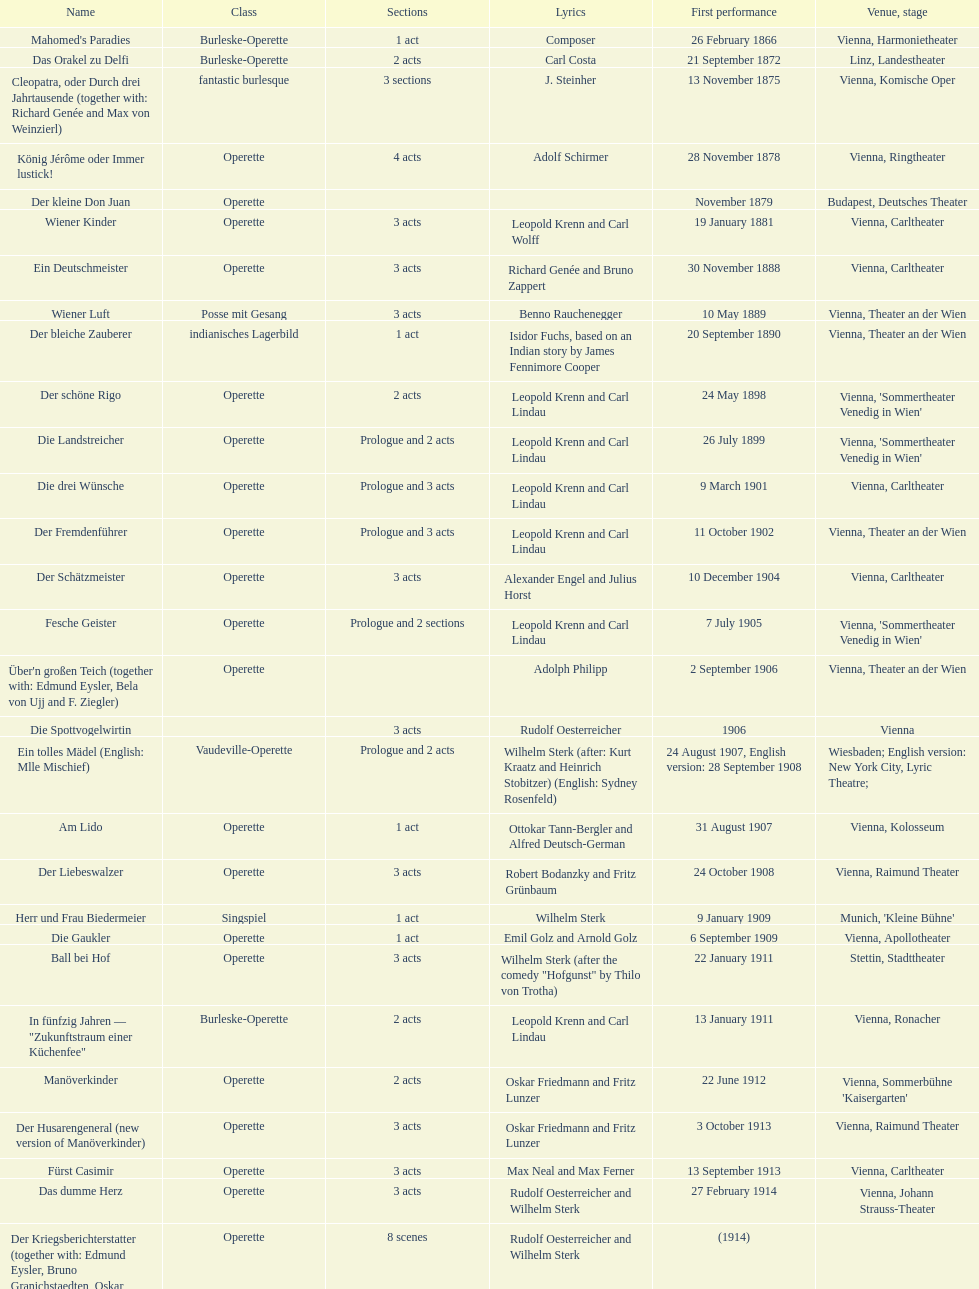Does der liebeswalzer or manöverkinder contain more acts? Der Liebeswalzer. 